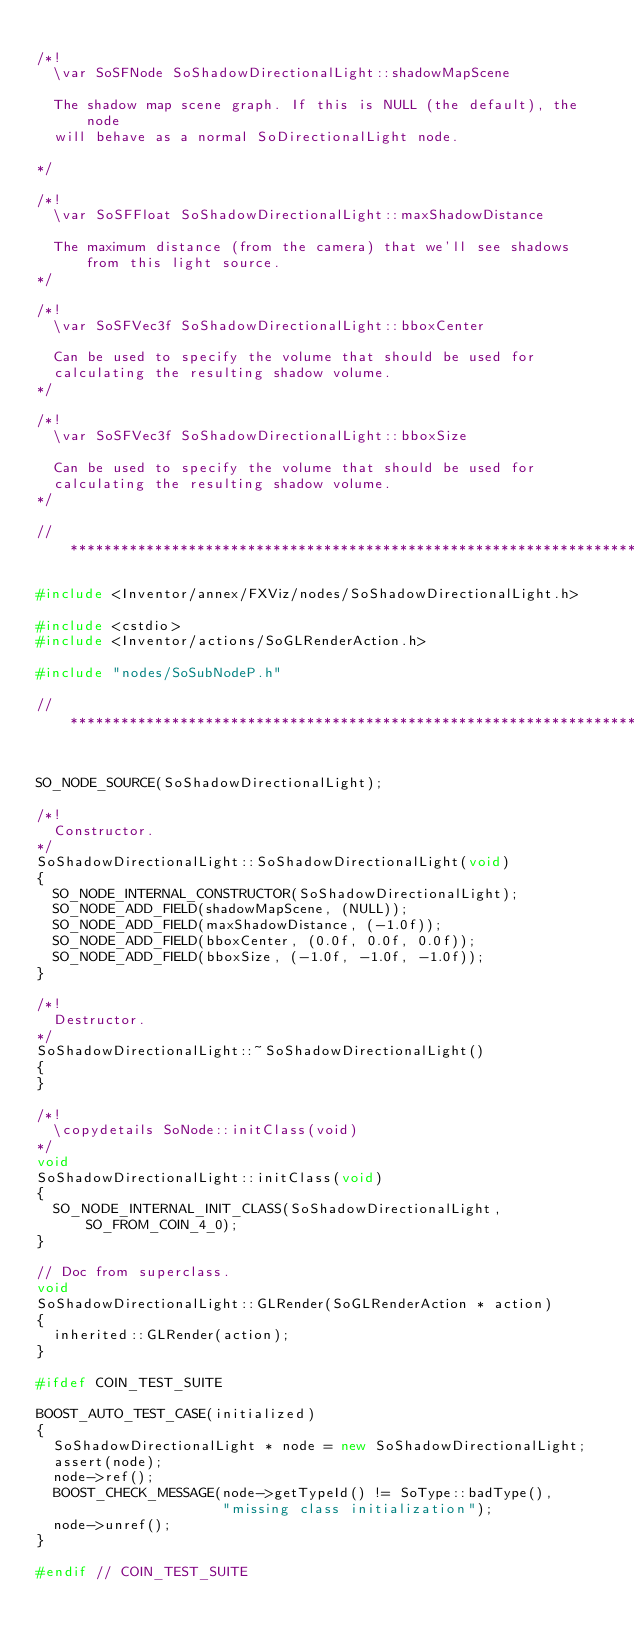<code> <loc_0><loc_0><loc_500><loc_500><_C++_>
/*!
  \var SoSFNode SoShadowDirectionalLight::shadowMapScene

  The shadow map scene graph. If this is NULL (the default), the node
  will behave as a normal SoDirectionalLight node.

*/

/*!
  \var SoSFFloat SoShadowDirectionalLight::maxShadowDistance

  The maximum distance (from the camera) that we'll see shadows from this light source.
*/

/*!
  \var SoSFVec3f SoShadowDirectionalLight::bboxCenter

  Can be used to specify the volume that should be used for
  calculating the resulting shadow volume.
*/

/*!
  \var SoSFVec3f SoShadowDirectionalLight::bboxSize

  Can be used to specify the volume that should be used for
  calculating the resulting shadow volume.
*/

// *************************************************************************

#include <Inventor/annex/FXViz/nodes/SoShadowDirectionalLight.h>

#include <cstdio>
#include <Inventor/actions/SoGLRenderAction.h>

#include "nodes/SoSubNodeP.h"

// *************************************************************************


SO_NODE_SOURCE(SoShadowDirectionalLight);

/*!
  Constructor.
*/
SoShadowDirectionalLight::SoShadowDirectionalLight(void)
{
  SO_NODE_INTERNAL_CONSTRUCTOR(SoShadowDirectionalLight);
  SO_NODE_ADD_FIELD(shadowMapScene, (NULL));
  SO_NODE_ADD_FIELD(maxShadowDistance, (-1.0f));
  SO_NODE_ADD_FIELD(bboxCenter, (0.0f, 0.0f, 0.0f));
  SO_NODE_ADD_FIELD(bboxSize, (-1.0f, -1.0f, -1.0f));
}

/*!
  Destructor.
*/
SoShadowDirectionalLight::~SoShadowDirectionalLight()
{
}

/*!
  \copydetails SoNode::initClass(void)
*/
void
SoShadowDirectionalLight::initClass(void)
{
  SO_NODE_INTERNAL_INIT_CLASS(SoShadowDirectionalLight, SO_FROM_COIN_4_0);
}

// Doc from superclass.
void
SoShadowDirectionalLight::GLRender(SoGLRenderAction * action)
{
  inherited::GLRender(action);
}

#ifdef COIN_TEST_SUITE

BOOST_AUTO_TEST_CASE(initialized)
{
  SoShadowDirectionalLight * node = new SoShadowDirectionalLight;
  assert(node);
  node->ref();
  BOOST_CHECK_MESSAGE(node->getTypeId() != SoType::badType(),
                      "missing class initialization");
  node->unref();
}

#endif // COIN_TEST_SUITE
</code> 